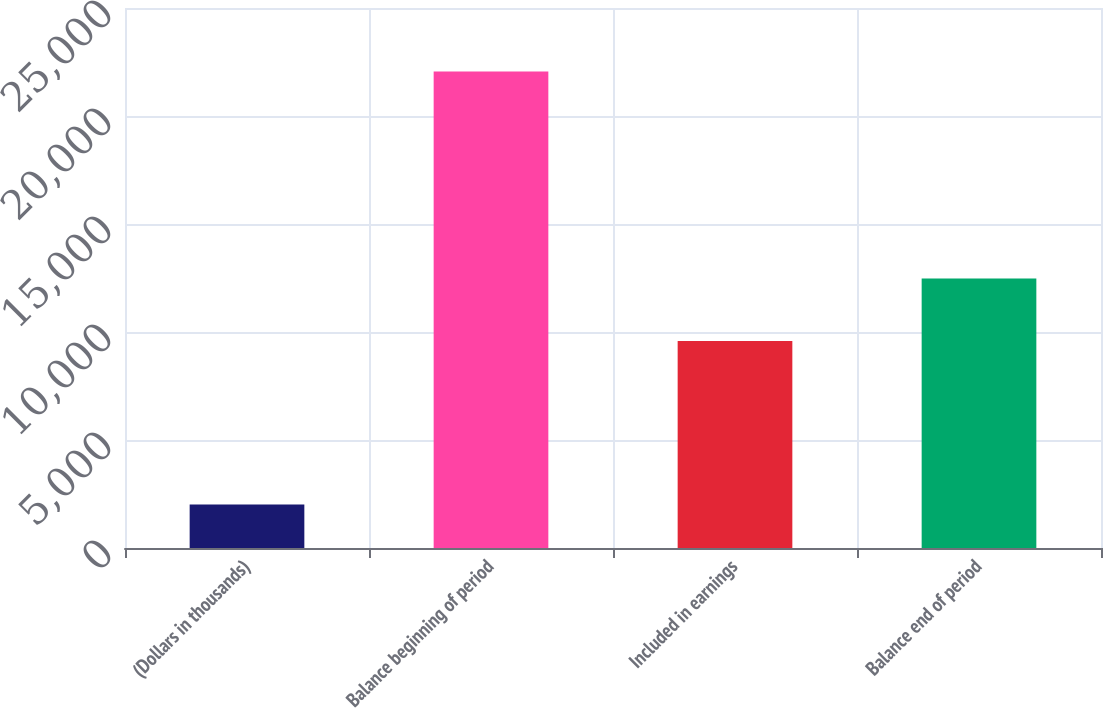<chart> <loc_0><loc_0><loc_500><loc_500><bar_chart><fcel>(Dollars in thousands)<fcel>Balance beginning of period<fcel>Included in earnings<fcel>Balance end of period<nl><fcel>2017<fcel>22059<fcel>9581<fcel>12477<nl></chart> 